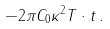Convert formula to latex. <formula><loc_0><loc_0><loc_500><loc_500>- 2 \pi C _ { 0 } \kappa ^ { 2 } T \cdot t \, .</formula> 